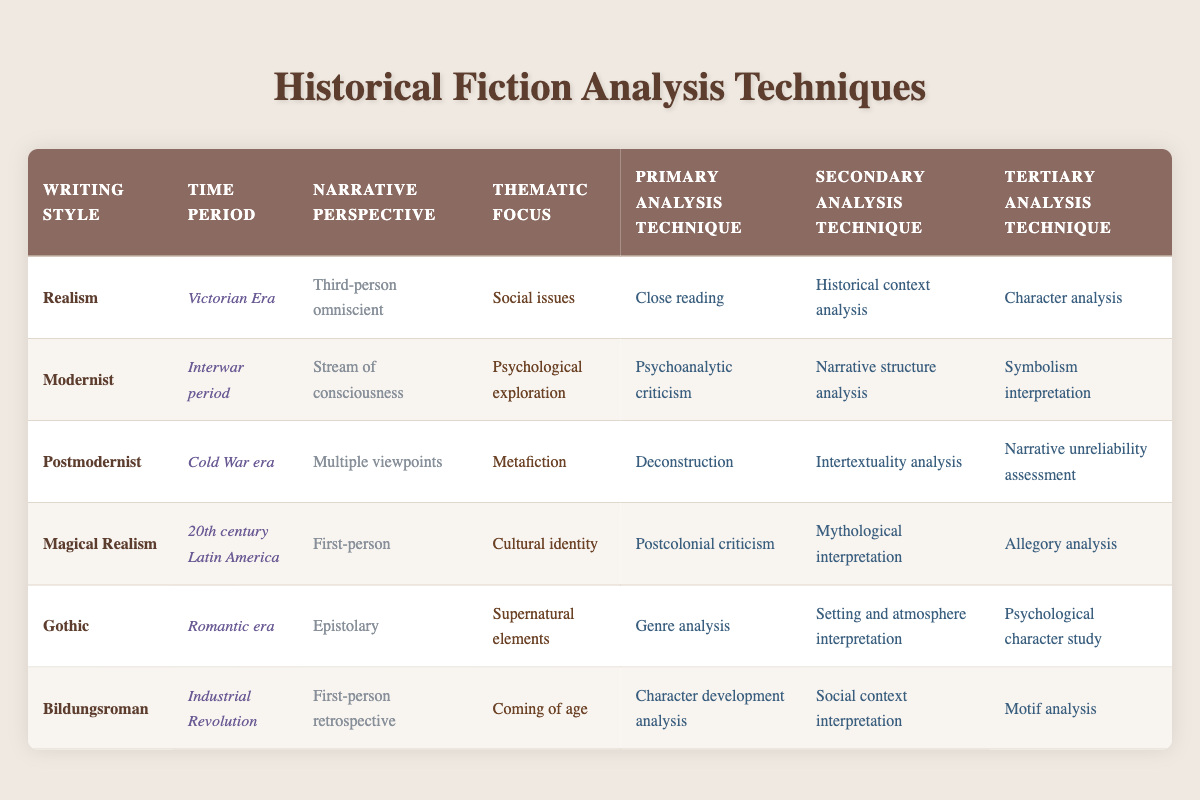What is the primary analysis technique for Magical Realism? In the row for Magical Realism, the primary analysis technique is listed as Postcolonial criticism.
Answer: Postcolonial criticism Which writing style is associated with the time period of the Industrial Revolution? The row for the Industrial Revolution shows that the writing style associated with it is Bildungsroman.
Answer: Bildungsroman True or False: The primary analysis technique for Gothic literature is Symbolism interpretation. The table indicates that the primary analysis technique for Gothic literature is Genre analysis, not Symbolism interpretation. Therefore, the statement is false.
Answer: False What are the narrative perspectives for both Modernist and Gothic writing styles? Referring to the respective rows, Modernist uses Stream of consciousness as its narrative perspective, while Gothic uses Epistolary.
Answer: Stream of consciousness and Epistolary How many analysis techniques are associated with the writing style Realism? Each row provides three techniques: primary, secondary, and tertiary. For Realism, the techniques listed are Close reading, Historical context analysis, and Character analysis, which sum up to three techniques.
Answer: Three Which thematic focus shares the same narrative perspective in both Postmodernist and Modernist styles? Looking at the narrative perspectives, Modernist has Stream of consciousness, and the thematic focus is Psychological exploration. Postmodernist has Multiple viewpoints, and its thematic focus is Metafiction. They do not share a narrative perspective.
Answer: None What is the difference between the primary analysis techniques for Realism and Modernist writing styles? The primary analysis technique for Realism is Close reading, while the one for Modernist is Psychoanalytic criticism. The difference is identified as two distinct techniques with different focal points.
Answer: Close reading and Psychoanalytic criticism What is the tertiary analysis technique for the Gothic writing style? Checking the Gothic row, the tertiary analysis technique is listed as Psychological character study.
Answer: Psychological character study 